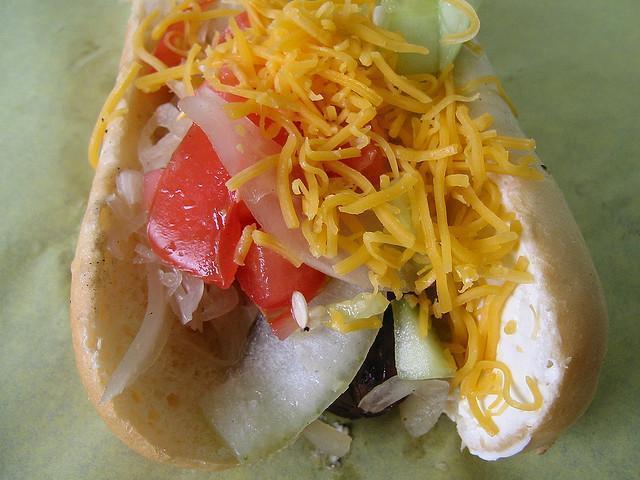How many cats are there in this picture?
Give a very brief answer. 0. 